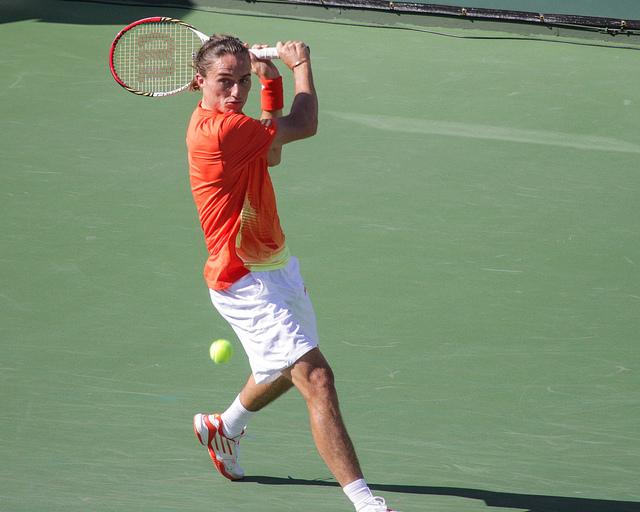What is he wearing on his head?
Concise answer only. Headband. What hairstyle is the tennis player wearing?
Quick response, please. Ponytail. Do you think he will hit the ball or miss?
Give a very brief answer. Hit. What brand of tennis shoes is the player wearing?
Short answer required. Adidas. What color is the ball?
Answer briefly. Yellow. What foot is back?
Give a very brief answer. Left. 